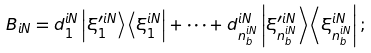<formula> <loc_0><loc_0><loc_500><loc_500>B _ { i N } = d _ { 1 } ^ { i N } \left | \xi _ { 1 } ^ { \prime i N } \right \rangle \left \langle \xi _ { 1 } ^ { i N } \right | + \cdots + d _ { n _ { b } ^ { i N } } ^ { i N } \left | \xi _ { n _ { b } ^ { i N } } ^ { \prime i N } \right \rangle \left \langle \xi _ { n _ { b } ^ { i N } } ^ { i N } \right | ;</formula> 